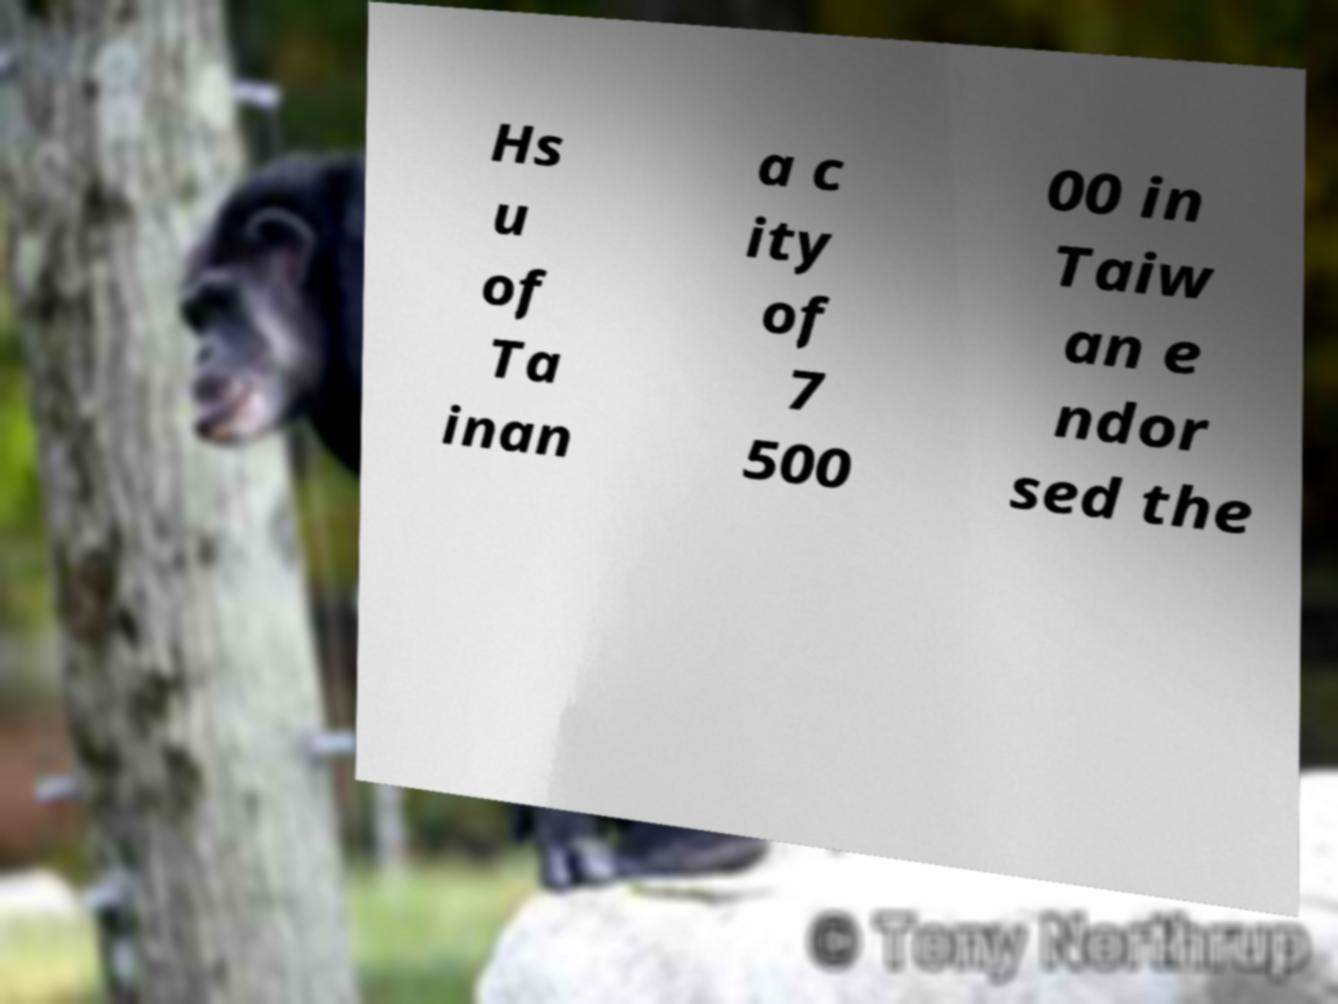What messages or text are displayed in this image? I need them in a readable, typed format. Hs u of Ta inan a c ity of 7 500 00 in Taiw an e ndor sed the 